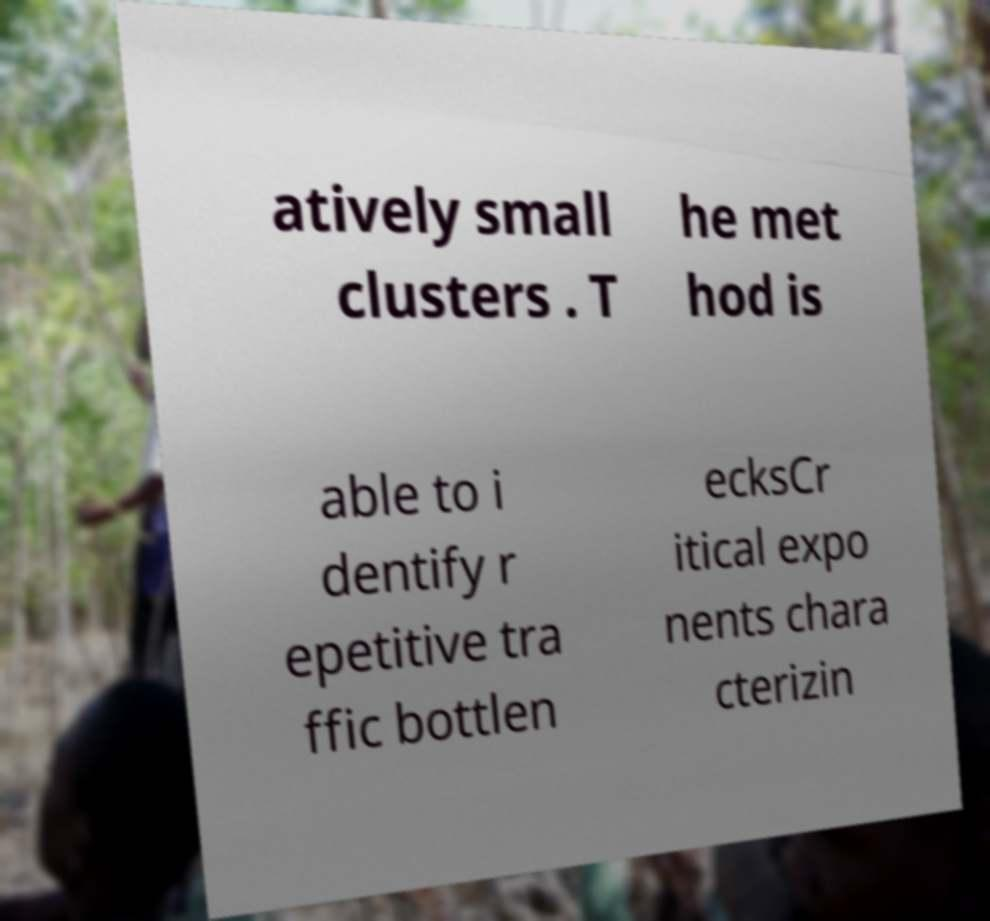Please read and relay the text visible in this image. What does it say? atively small clusters . T he met hod is able to i dentify r epetitive tra ffic bottlen ecksCr itical expo nents chara cterizin 